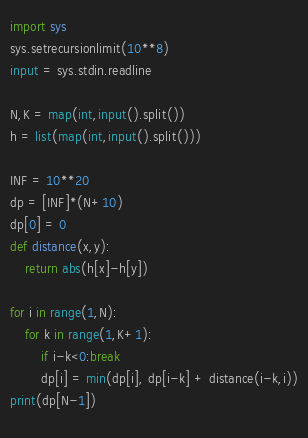<code> <loc_0><loc_0><loc_500><loc_500><_Python_>
import sys
sys.setrecursionlimit(10**8)
input = sys.stdin.readline

N,K = map(int,input().split())
h = list(map(int,input().split()))

INF = 10**20
dp = [INF]*(N+10)
dp[0] = 0
def distance(x,y):
    return abs(h[x]-h[y])

for i in range(1,N):
    for k in range(1,K+1):
        if i-k<0:break
        dp[i] = min(dp[i], dp[i-k] + distance(i-k,i))
print(dp[N-1])
    </code> 